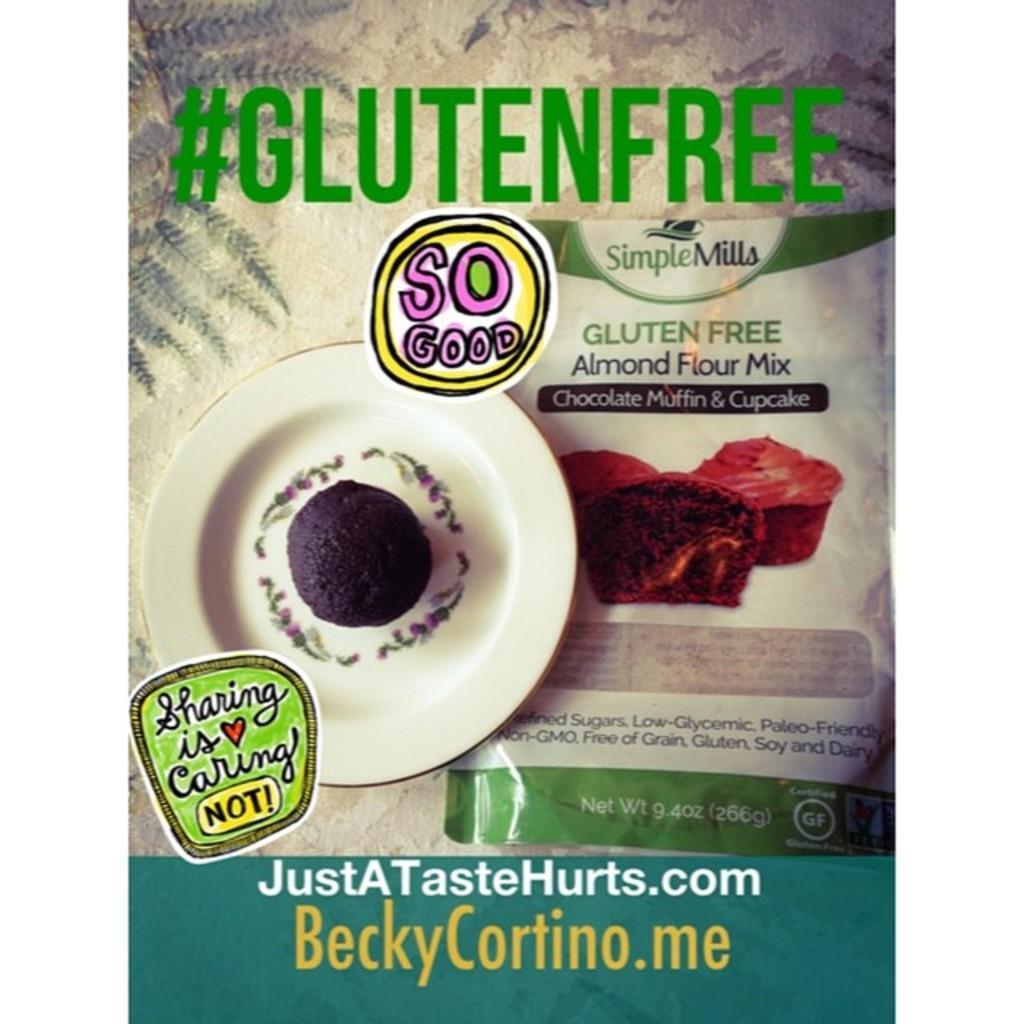Please provide a concise description of this image. On the left side of the image a cake is present on the plate. On the right side of the image we can see a packet. In the background of the image some text is there. 